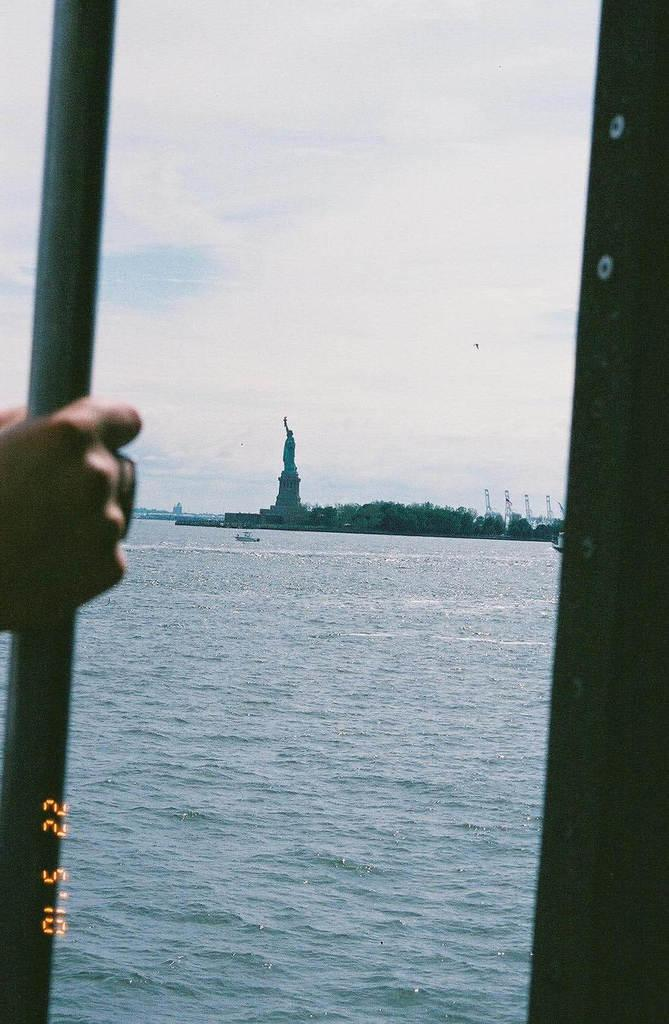What is the main subject in the image? There is a statue in the image. What other elements can be seen in the image? There are trees, towers, boats, and water visible in the image. What is the person in the image holding? The person is holding a pole in the image. How would you describe the sky in the image? The sky is in white and blue color. What type of tax is being discussed by the statue in the image? There is no discussion of tax in the image, as it features a statue and other elements. Can you see any pickles in the image? There are no pickles present in the image. 